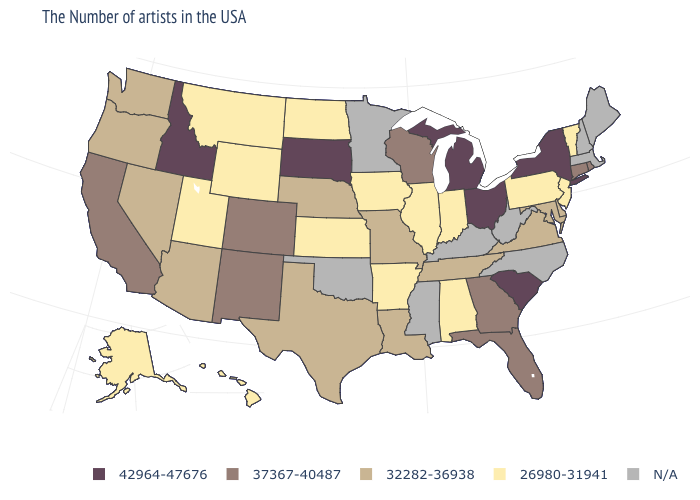Among the states that border Washington , does Oregon have the highest value?
Answer briefly. No. What is the value of Missouri?
Write a very short answer. 32282-36938. Which states have the lowest value in the West?
Concise answer only. Wyoming, Utah, Montana, Alaska, Hawaii. What is the value of Indiana?
Be succinct. 26980-31941. What is the lowest value in the West?
Quick response, please. 26980-31941. What is the highest value in states that border Utah?
Answer briefly. 42964-47676. What is the value of Iowa?
Concise answer only. 26980-31941. Does Wyoming have the highest value in the USA?
Give a very brief answer. No. Name the states that have a value in the range 37367-40487?
Quick response, please. Rhode Island, Connecticut, Florida, Georgia, Wisconsin, Colorado, New Mexico, California. Name the states that have a value in the range N/A?
Concise answer only. Maine, Massachusetts, New Hampshire, North Carolina, West Virginia, Kentucky, Mississippi, Minnesota, Oklahoma. What is the value of California?
Be succinct. 37367-40487. Does Idaho have the highest value in the USA?
Concise answer only. Yes. 